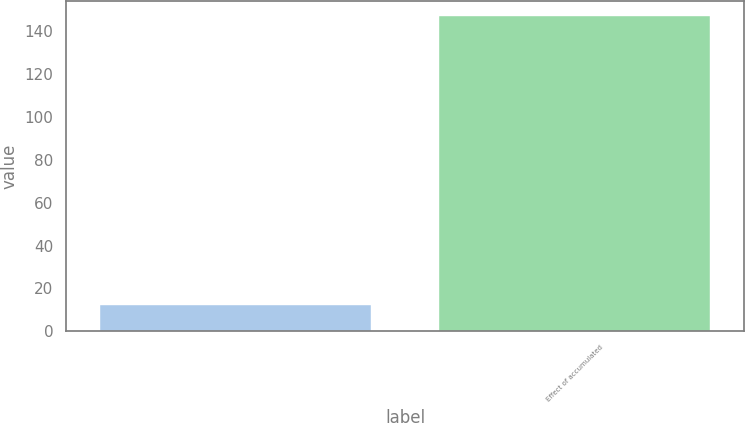Convert chart to OTSL. <chart><loc_0><loc_0><loc_500><loc_500><bar_chart><ecel><fcel>Effect of accumulated<nl><fcel>12<fcel>147<nl></chart> 